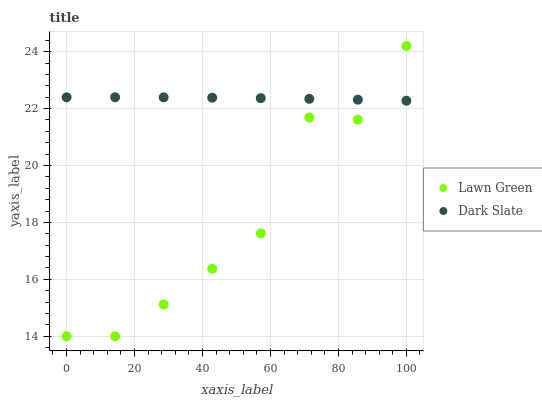Does Lawn Green have the minimum area under the curve?
Answer yes or no. Yes. Does Dark Slate have the maximum area under the curve?
Answer yes or no. Yes. Does Dark Slate have the minimum area under the curve?
Answer yes or no. No. Is Dark Slate the smoothest?
Answer yes or no. Yes. Is Lawn Green the roughest?
Answer yes or no. Yes. Is Dark Slate the roughest?
Answer yes or no. No. Does Lawn Green have the lowest value?
Answer yes or no. Yes. Does Dark Slate have the lowest value?
Answer yes or no. No. Does Lawn Green have the highest value?
Answer yes or no. Yes. Does Dark Slate have the highest value?
Answer yes or no. No. Does Dark Slate intersect Lawn Green?
Answer yes or no. Yes. Is Dark Slate less than Lawn Green?
Answer yes or no. No. Is Dark Slate greater than Lawn Green?
Answer yes or no. No. 